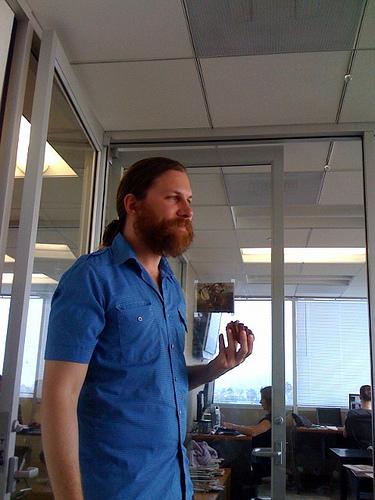What color is the man's shirt?
Give a very brief answer. Blue. What kind of facial hair does the man have?
Quick response, please. Beard. What is this man holding?
Give a very brief answer. Donut. 